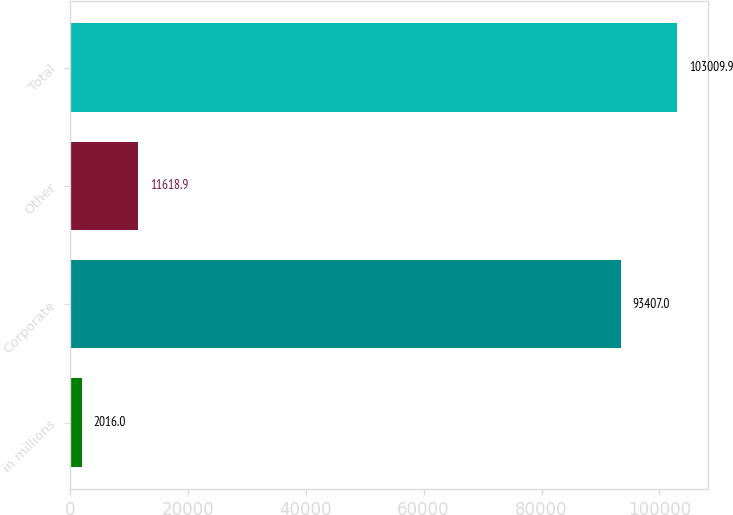Convert chart to OTSL. <chart><loc_0><loc_0><loc_500><loc_500><bar_chart><fcel>in millions<fcel>Corporate<fcel>Other<fcel>Total<nl><fcel>2016<fcel>93407<fcel>11618.9<fcel>103010<nl></chart> 